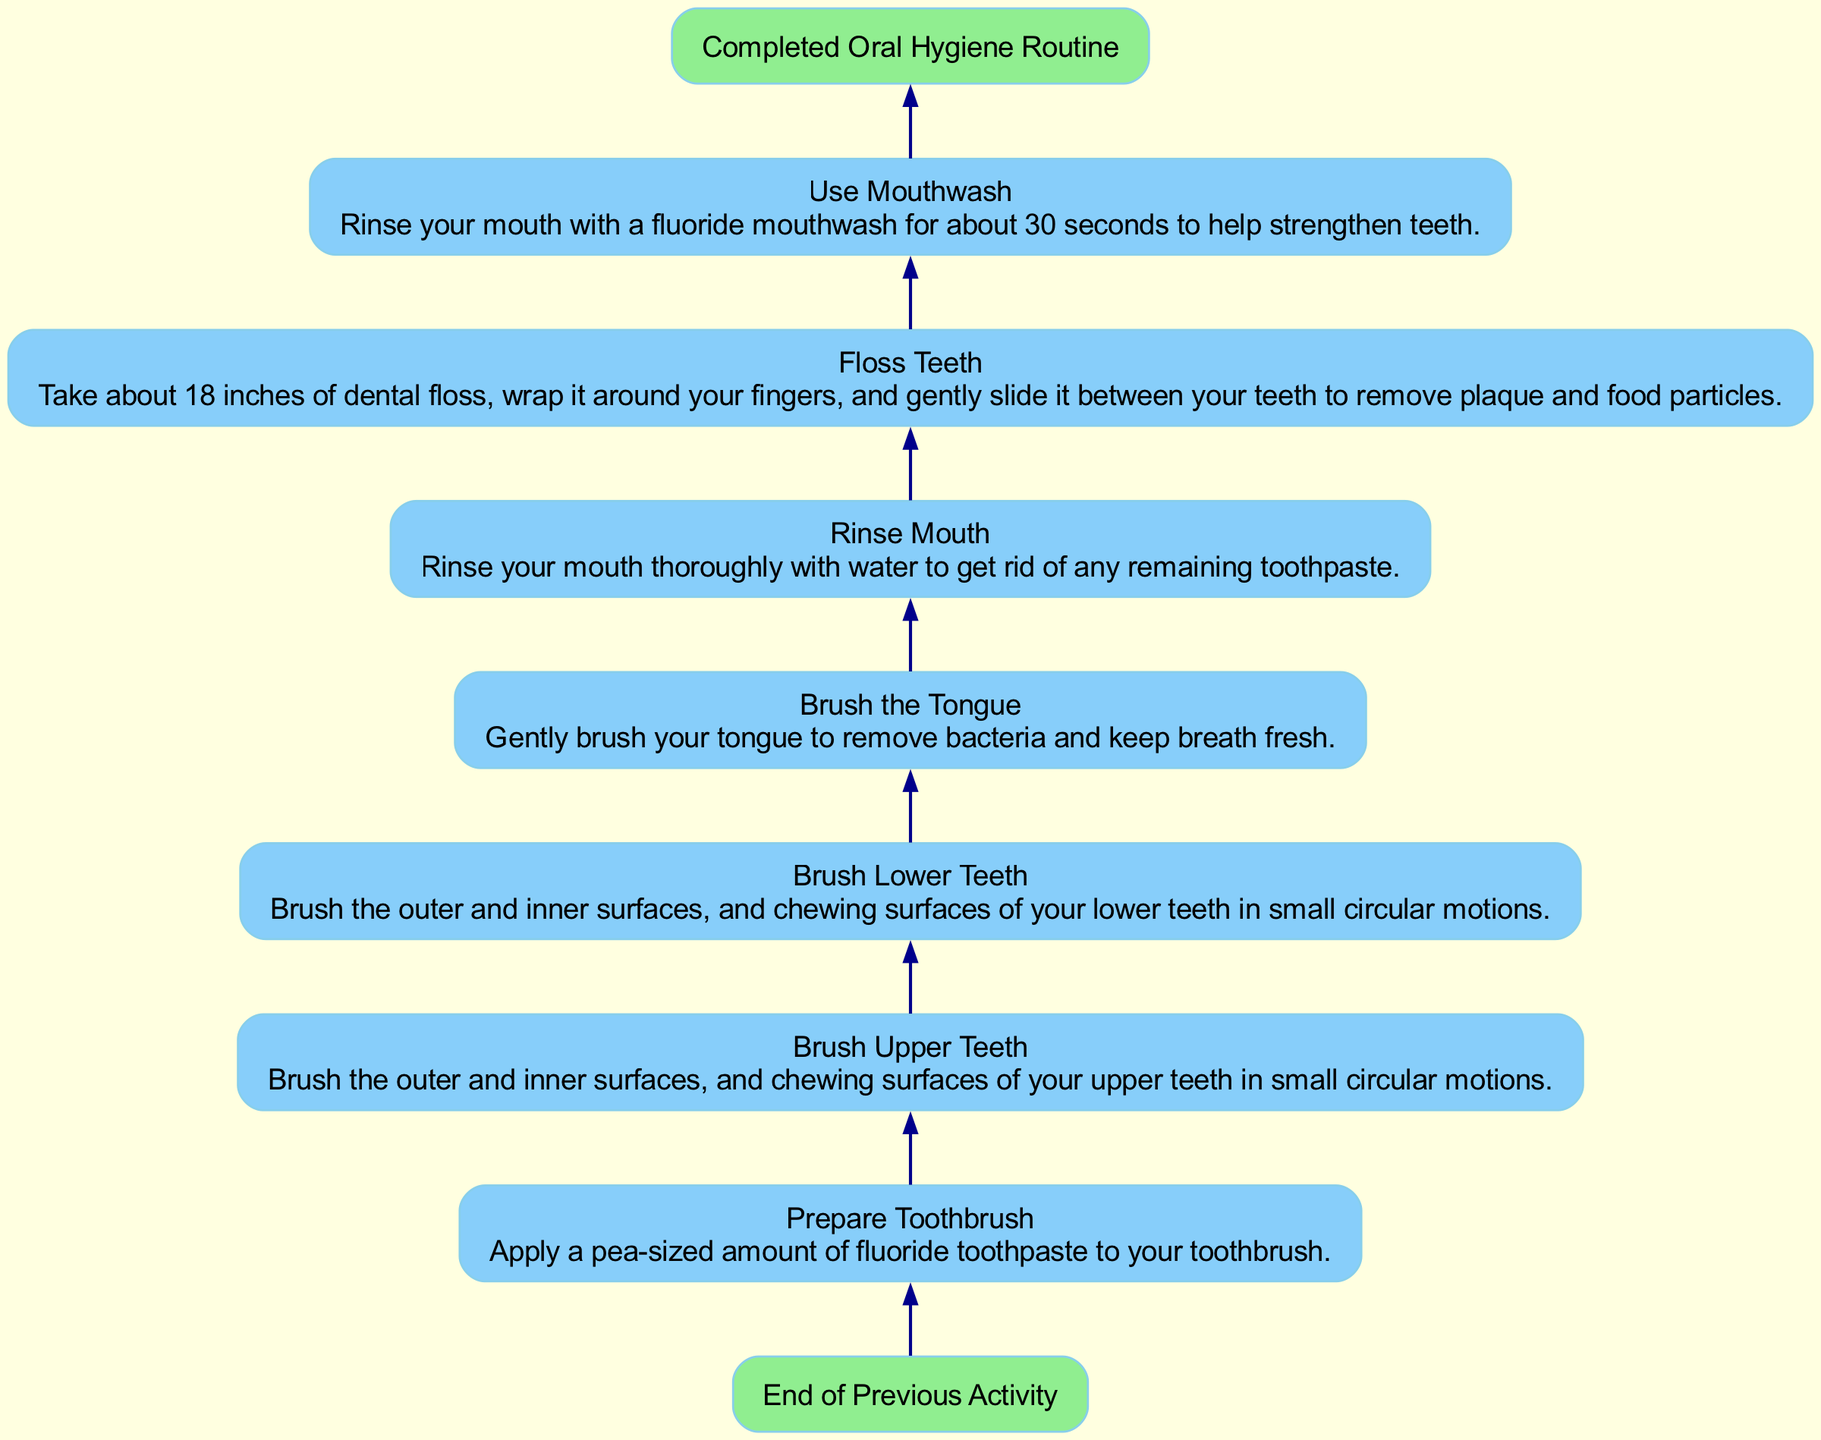What is the first step in the oral hygiene routine? The first step in the oral hygiene routine is indicated by the first node after the starting point, which is "Prepare Toothbrush." This step involves applying toothpaste to the toothbrush.
Answer: Prepare Toothbrush What action follows rinsing the mouth? To determine the action that follows rinsing the mouth, look at the diagram flow. After "Rinse Mouth," the next step is "Floss Teeth."
Answer: Floss Teeth How many total steps are there in the routine? Count the individual steps listed in the diagram. There are seven steps, starting from "Prepare Toothbrush" to "Use Mouthwash."
Answer: 7 What is the last step of the routine? The last step, indicated just before the ending point in the flow chart, is "Use Mouthwash." This step is the final action taken before completing the routine.
Answer: Use Mouthwash What color represents the steps in the diagram? Look at the design specifications of the nodes in the flow chart. The steps are represented in "lightskyblue."
Answer: lightskyblue Which step includes removing bacteria from the tongue? Trace through the steps to find which one specifically mentions the tongue. The step that mentions this action is "Brush the Tongue."
Answer: Brush the Tongue Do you use mouthwash before or after flossing? To answer this, follow the order of the steps in the diagram. "Use Mouthwash" is after "Floss Teeth," indicating that mouthwash is used after flossing.
Answer: After What is the overall flow direction of the chart? The flow direction of the chart is specified at the beginning; it flows from the bottom to the top, indicating how the steps progress.
Answer: Bottom to Top What happens at the starting point of the routine? The starting point of the routine is labeled "End of Previous Activity," serving as the entry point into the oral hygiene steps outlined in the diagram.
Answer: End of Previous Activity 